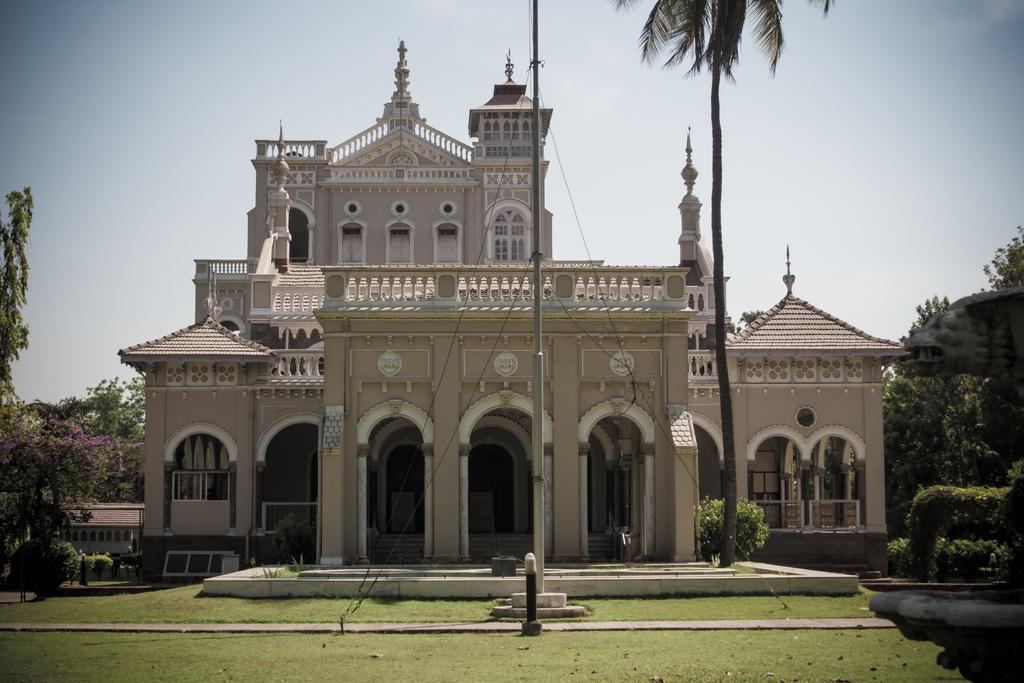What type of vegetation is present in the image? There is grass in the image. What type of structure can be seen in the image? There is a building in the image. What other natural elements are present in the image? There are trees in the image. What object is standing upright in the image? There is a pole in the image. What can be seen in the distance in the image? The sky is visible in the background of the image. How does the grass move in the image? The grass does not move in the image; it is stationary. What happens to the building when it is smashed in the image? There is no indication of the building being smashed in the image. What type of expansion is shown in the image? There is no expansion shown in the image; it depicts a stationary scene. 